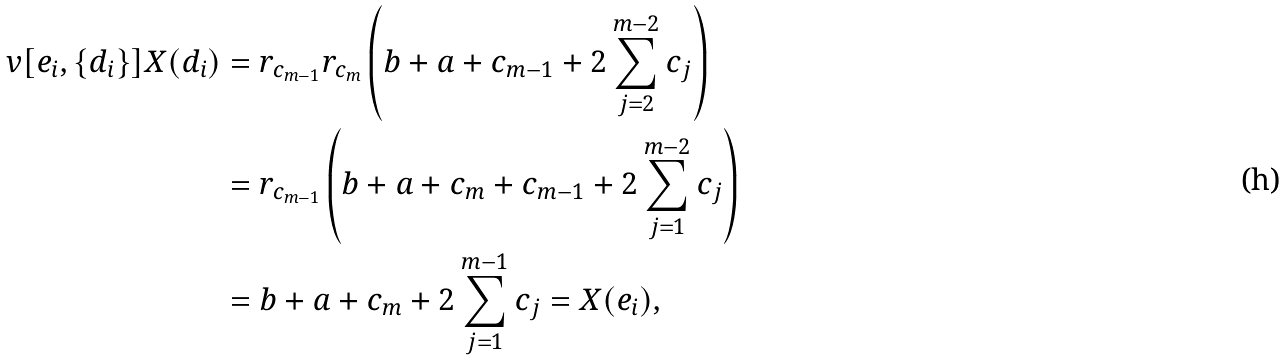Convert formula to latex. <formula><loc_0><loc_0><loc_500><loc_500>v [ e _ { i } , \{ d _ { i } \} ] X ( d _ { i } ) & = r _ { c _ { m - 1 } } r _ { c _ { m } } \left ( b + a + c _ { m - 1 } + 2 \sum _ { j = 2 } ^ { m - 2 } c _ { j } \right ) \\ & = r _ { c _ { m - 1 } } \left ( b + a + c _ { m } + c _ { m - 1 } + 2 \sum _ { j = 1 } ^ { m - 2 } c _ { j } \right ) \\ & = b + a + c _ { m } + 2 \sum _ { j = 1 } ^ { m - 1 } c _ { j } = X ( e _ { i } ) ,</formula> 